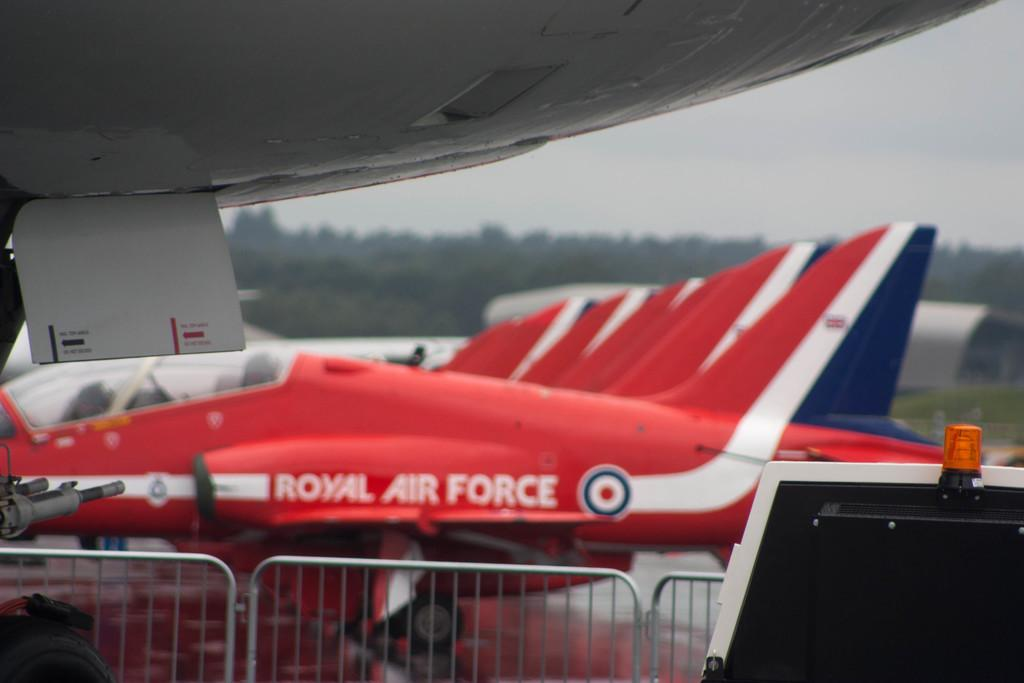Provide a one-sentence caption for the provided image. Royal Air France jets are lined up and photographed from the side. 